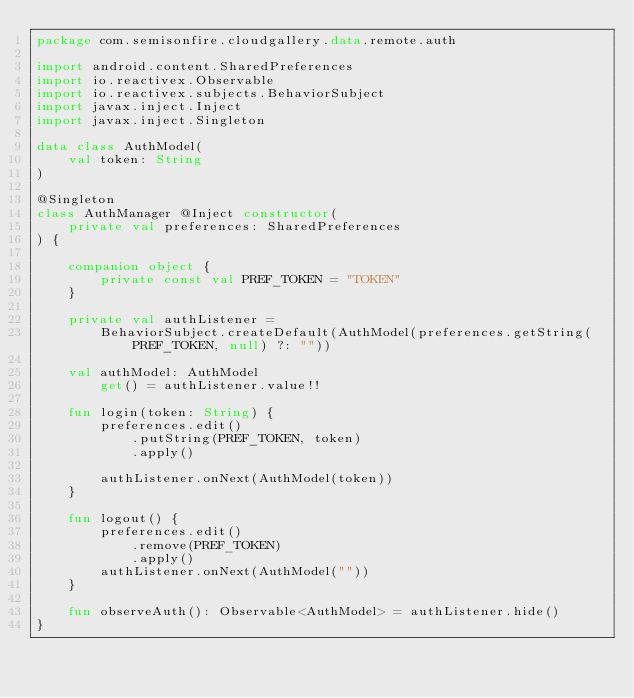Convert code to text. <code><loc_0><loc_0><loc_500><loc_500><_Kotlin_>package com.semisonfire.cloudgallery.data.remote.auth

import android.content.SharedPreferences
import io.reactivex.Observable
import io.reactivex.subjects.BehaviorSubject
import javax.inject.Inject
import javax.inject.Singleton

data class AuthModel(
    val token: String
)

@Singleton
class AuthManager @Inject constructor(
    private val preferences: SharedPreferences
) {

    companion object {
        private const val PREF_TOKEN = "TOKEN"
    }

    private val authListener =
        BehaviorSubject.createDefault(AuthModel(preferences.getString(PREF_TOKEN, null) ?: ""))

    val authModel: AuthModel
        get() = authListener.value!!

    fun login(token: String) {
        preferences.edit()
            .putString(PREF_TOKEN, token)
            .apply()

        authListener.onNext(AuthModel(token))
    }

    fun logout() {
        preferences.edit()
            .remove(PREF_TOKEN)
            .apply()
        authListener.onNext(AuthModel(""))
    }

    fun observeAuth(): Observable<AuthModel> = authListener.hide()
}</code> 